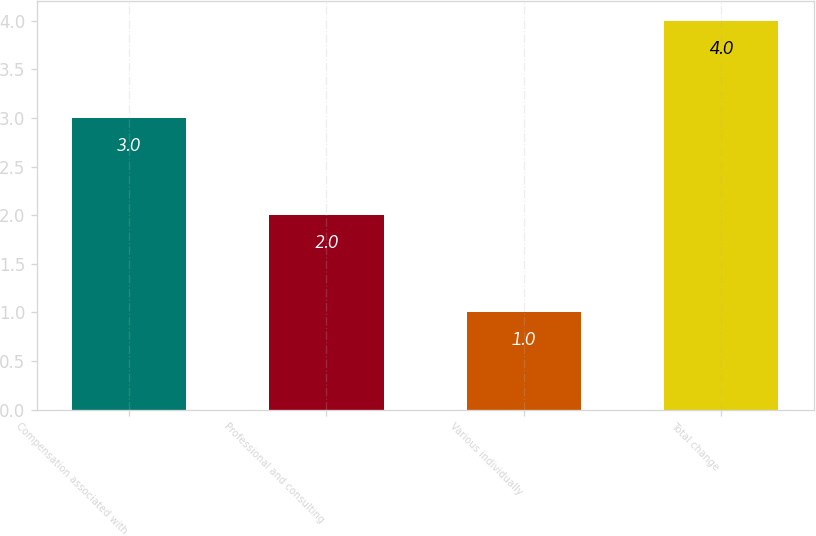Convert chart to OTSL. <chart><loc_0><loc_0><loc_500><loc_500><bar_chart><fcel>Compensation associated with<fcel>Professional and consulting<fcel>Various individually<fcel>Total change<nl><fcel>3<fcel>2<fcel>1<fcel>4<nl></chart> 